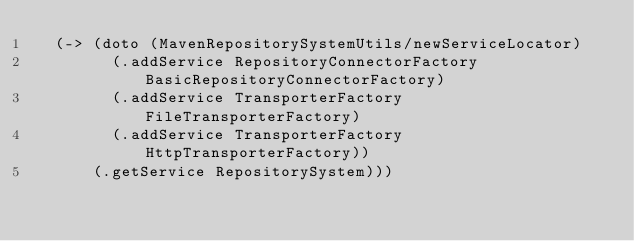Convert code to text. <code><loc_0><loc_0><loc_500><loc_500><_Clojure_>  (-> (doto (MavenRepositorySystemUtils/newServiceLocator)
        (.addService RepositoryConnectorFactory BasicRepositoryConnectorFactory)
        (.addService TransporterFactory FileTransporterFactory)
        (.addService TransporterFactory HttpTransporterFactory))
      (.getService RepositorySystem)))
</code> 